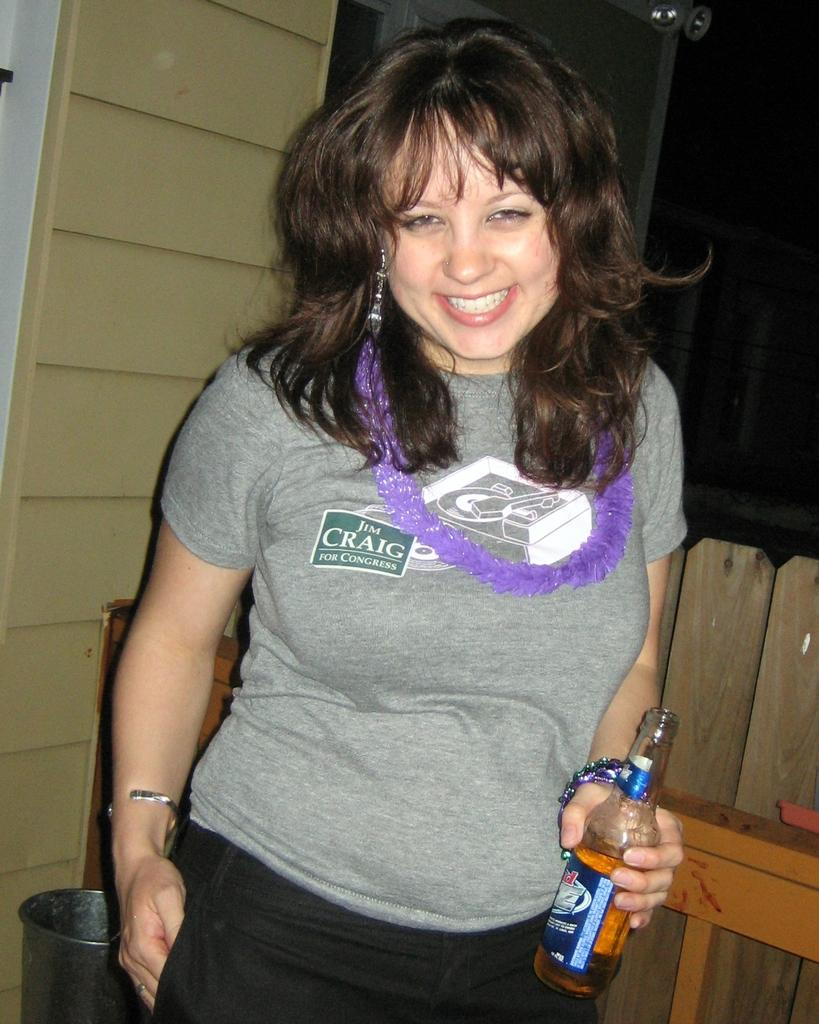<image>
Present a compact description of the photo's key features. the woman is wearing a t-shirt saying Jim Craig for Congress 